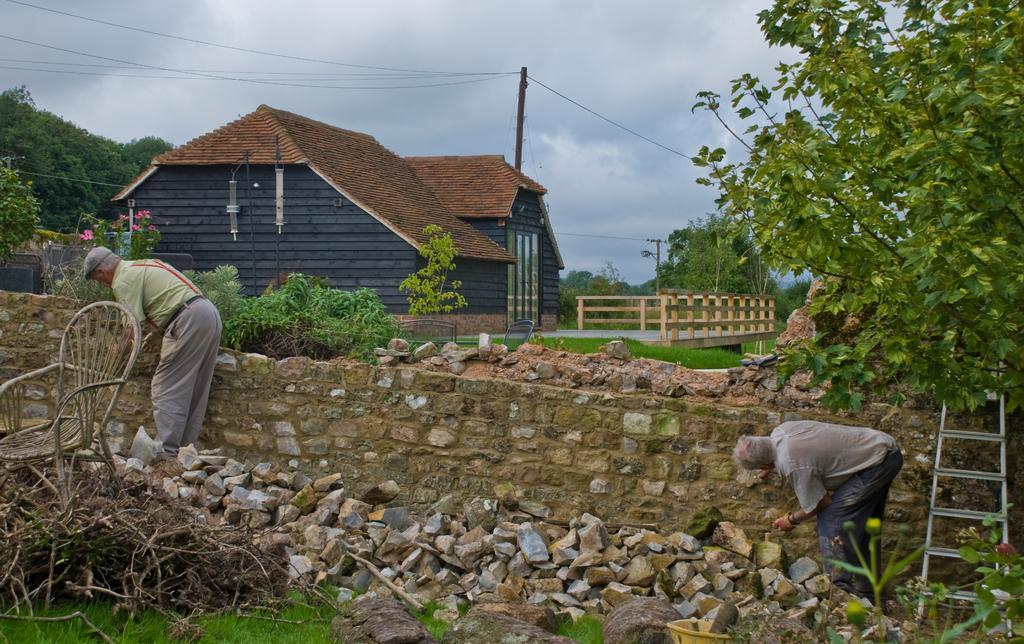In one or two sentences, can you explain what this image depicts? In this picture I can see there are two people standing at the wall and there is grass on the floor, there are twigs and a wooden chair at left, there are few rocks, a ladder at the right side. There is a tree and a building in the backdrop, there is a bridge and a pole, there are trees at left and the sky is cloudy. 